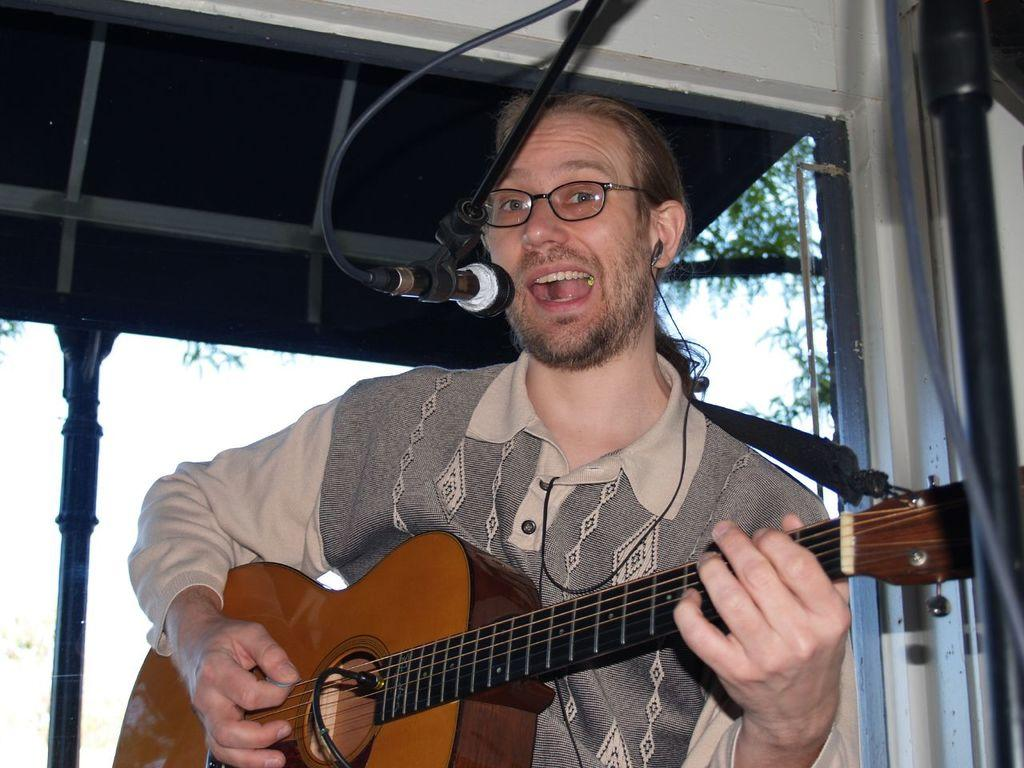What is the man in the image doing? The man is playing a guitar and singing. What object is in front of the man? There is a microphone in front of the man. What can be seen in the background of the image? There is a shed, a pole, and a tree in the background. What type of behavior does the bear exhibit in the image? There is no bear present in the image, so it is not possible to answer that question. 